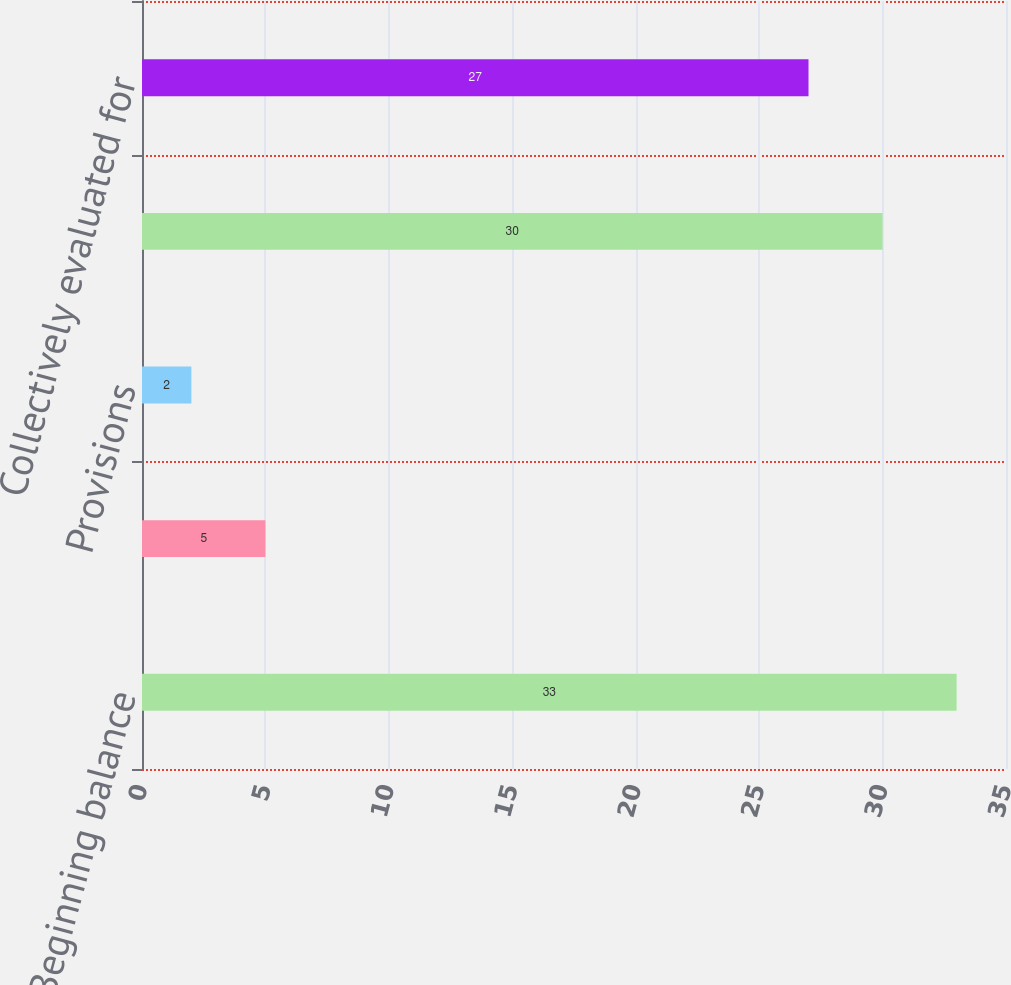Convert chart to OTSL. <chart><loc_0><loc_0><loc_500><loc_500><bar_chart><fcel>Beginning balance<fcel>Charge-offs<fcel>Provisions<fcel>Ending balance<fcel>Collectively evaluated for<nl><fcel>33<fcel>5<fcel>2<fcel>30<fcel>27<nl></chart> 